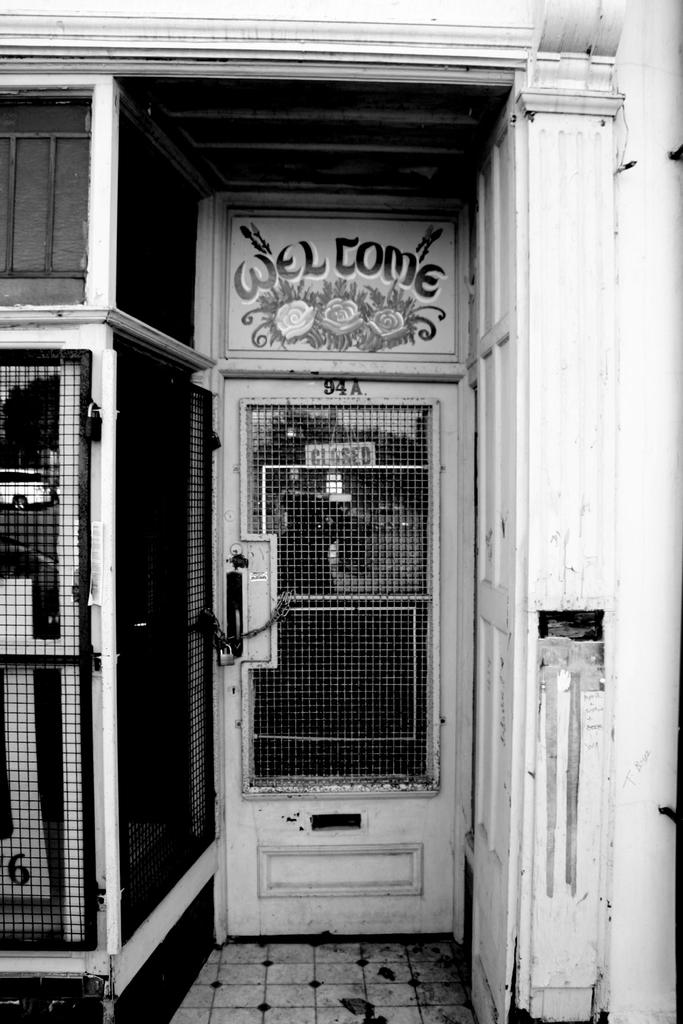What is the color scheme of the image? The image is black and white. What can be seen on the building in the image? There is a door of a building in the image. What is written or depicted on the door? There is some text on the door. What other objects are present in the image? There is a board and a grill in the image. How is the door secured? There is a lock on the door. What type of transport is shown in the image? There is no transport visible in the image; it features a door of a building with a lock, text, and other objects. Is there any evidence of a battle taking place in the image? No, there is no evidence of a battle in the image. 